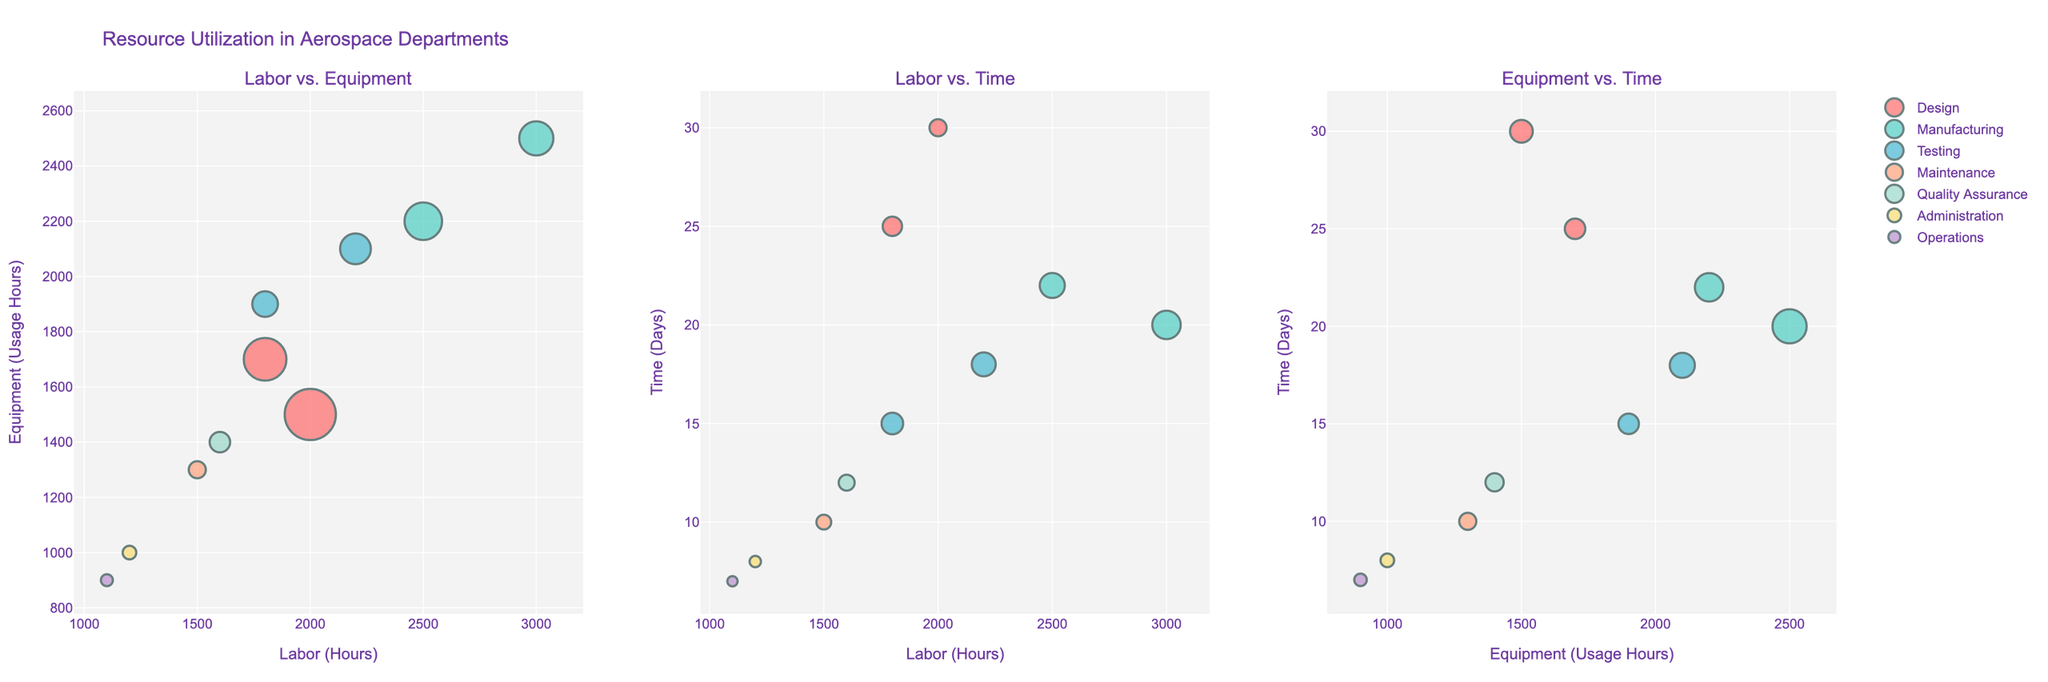What's the title of the figure? The title is displayed at the top of the figure. It reads "Resource Utilization in Aerospace Departments".
Answer: Resource Utilization in Aerospace Departments How many subplots are there in the figure? By observing the layout, it's clear that there are three distinct scatter plots side by side in the figure.
Answer: 3 Which department utilizes the most labor hours? In the Labor vs. Equipment subplot, look for the data point farthest to the right on the x-axis. The "Manufacturing" department, with "Wing Assembly" task, has the maximum labor usage of 3000 hours.
Answer: Manufacturing Which department has the shortest task duration? In the Labor vs. Time subplot, look for the data point closest to the bottom of the y-axis. The "Operations" department, with "Logistics Support" task, has the shortest time of 7 days.
Answer: Operations Are there any departments that use the same amount of equipment hours but differ in labor hours? By comparing the dots in the Labor vs. Equipment subplot, look for points with the same y-coordinate but different x-coordinates. "Design" (Aircraft Design with 1500 equipment hours) and "Testing" (Flight Testing with 1500 equipment hours) are not equal in labor hours.
Answer: No Which department's task has the highest time duration and what is its equipment usage? Focus on the data points in the Equipment vs. Time subplot and find the point at the top of the y-axis. The "Design" department, with "Aircraft Design", has the highest time duration of 30 days and its equipment usage is 1500 hours.
Answer: Design, 1500 Comparing "Fuselage Assembly" and "Engine Testing", which task uses more labor hours? The Labor vs. Equipment subplot shows "Fuselage Assembly" at 2500 hours and "Engine Testing" at 2200 hours on the x-axis. So, "Fuselage Assembly" uses more labor hours.
Answer: Fuselage Assembly In the Labor vs. Equipment subplot, which department's task is located at the farthest left? Identify the point closest to the origin along the x-axis which indicates minimum labor usage. The "Operations" department, with the "Logistics Support" task, is at the far left with 1100 labor hours.
Answer: Operations Considering the scatter plot of Equipment vs. Time, which task has the highest equipment usage and what department does it belong to? The farthest right point represents the maximum equipment usage. "Fuselage Assembly" from the "Manufacturing" department has the highest equipment usage of 2500 hours.
Answer: Manufacturing What's the average labor hours utilized by departments in the given dataset? Sum the labor hours from all departments and divide by the number of departments: (2000 + 1800 + 3000 + 2500 + 2200 + 1800 + 1500 + 1600 + 1200 + 1100) / 10 = 18700 / 10. The result is 1870.
Answer: 1870 